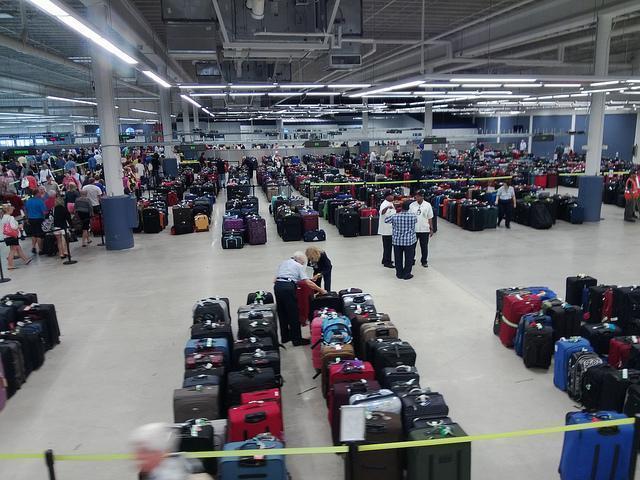How many people can be seen?
Give a very brief answer. 2. How many suitcases are there?
Give a very brief answer. 2. 